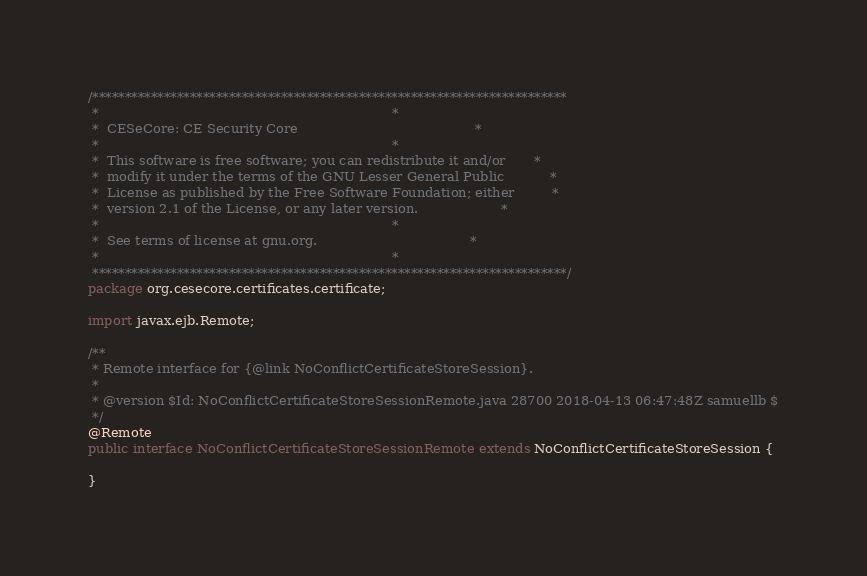Convert code to text. <code><loc_0><loc_0><loc_500><loc_500><_Java_>/*************************************************************************
 *                                                                       *
 *  CESeCore: CE Security Core                                           *
 *                                                                       *
 *  This software is free software; you can redistribute it and/or       *
 *  modify it under the terms of the GNU Lesser General Public           *
 *  License as published by the Free Software Foundation; either         *
 *  version 2.1 of the License, or any later version.                    *
 *                                                                       *
 *  See terms of license at gnu.org.                                     *
 *                                                                       *
 *************************************************************************/
package org.cesecore.certificates.certificate;

import javax.ejb.Remote;

/**
 * Remote interface for {@link NoConflictCertificateStoreSession}.
 * 
 * @version $Id: NoConflictCertificateStoreSessionRemote.java 28700 2018-04-13 06:47:48Z samuellb $
 */
@Remote
public interface NoConflictCertificateStoreSessionRemote extends NoConflictCertificateStoreSession {

}
</code> 